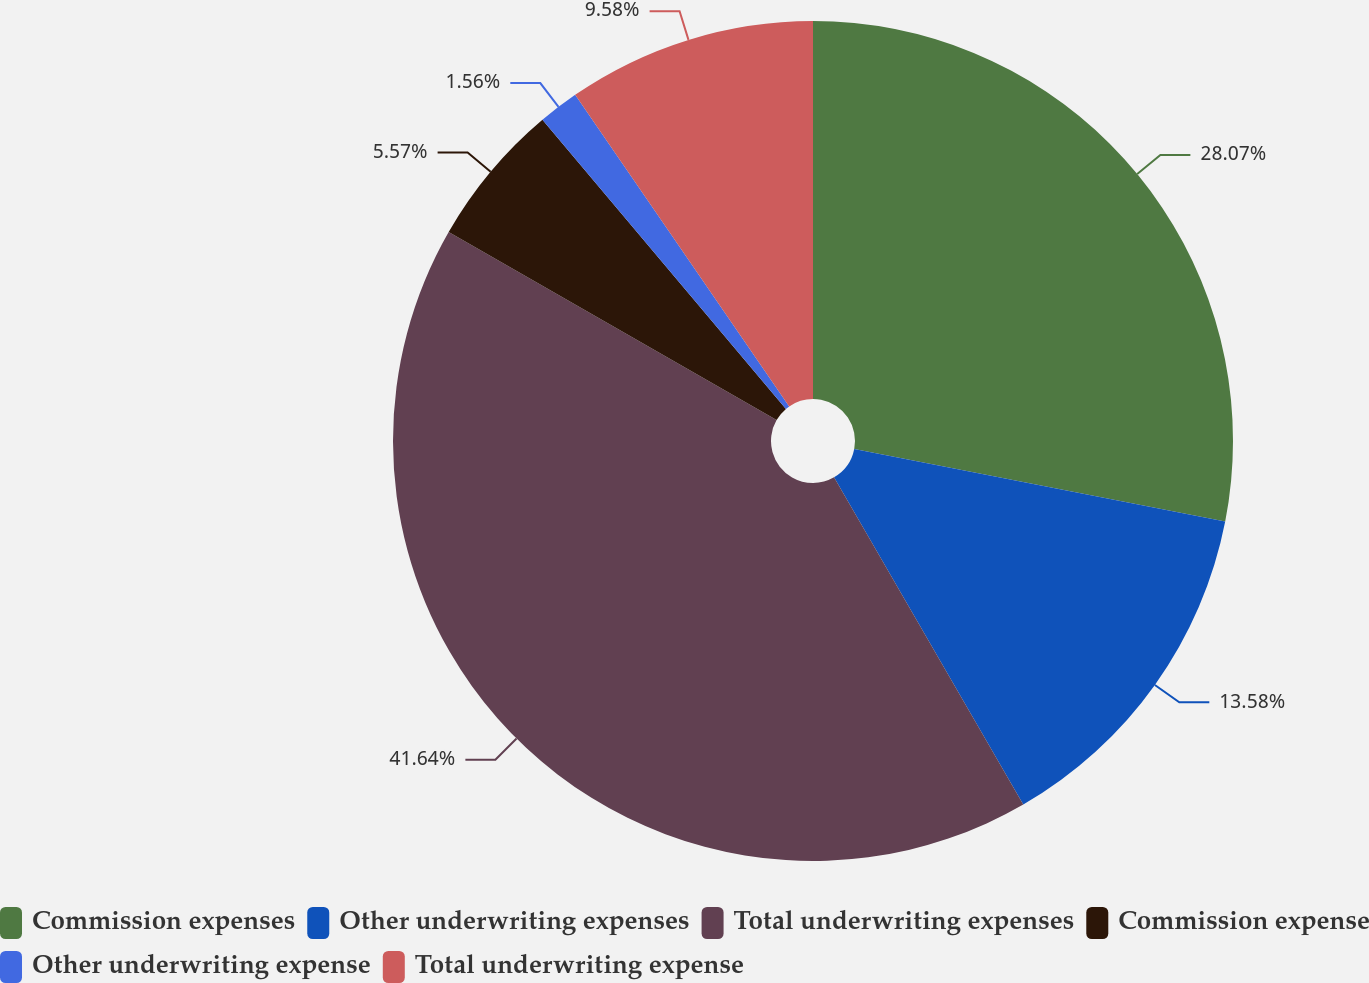Convert chart. <chart><loc_0><loc_0><loc_500><loc_500><pie_chart><fcel>Commission expenses<fcel>Other underwriting expenses<fcel>Total underwriting expenses<fcel>Commission expense<fcel>Other underwriting expense<fcel>Total underwriting expense<nl><fcel>28.07%<fcel>13.58%<fcel>41.63%<fcel>5.57%<fcel>1.56%<fcel>9.58%<nl></chart> 